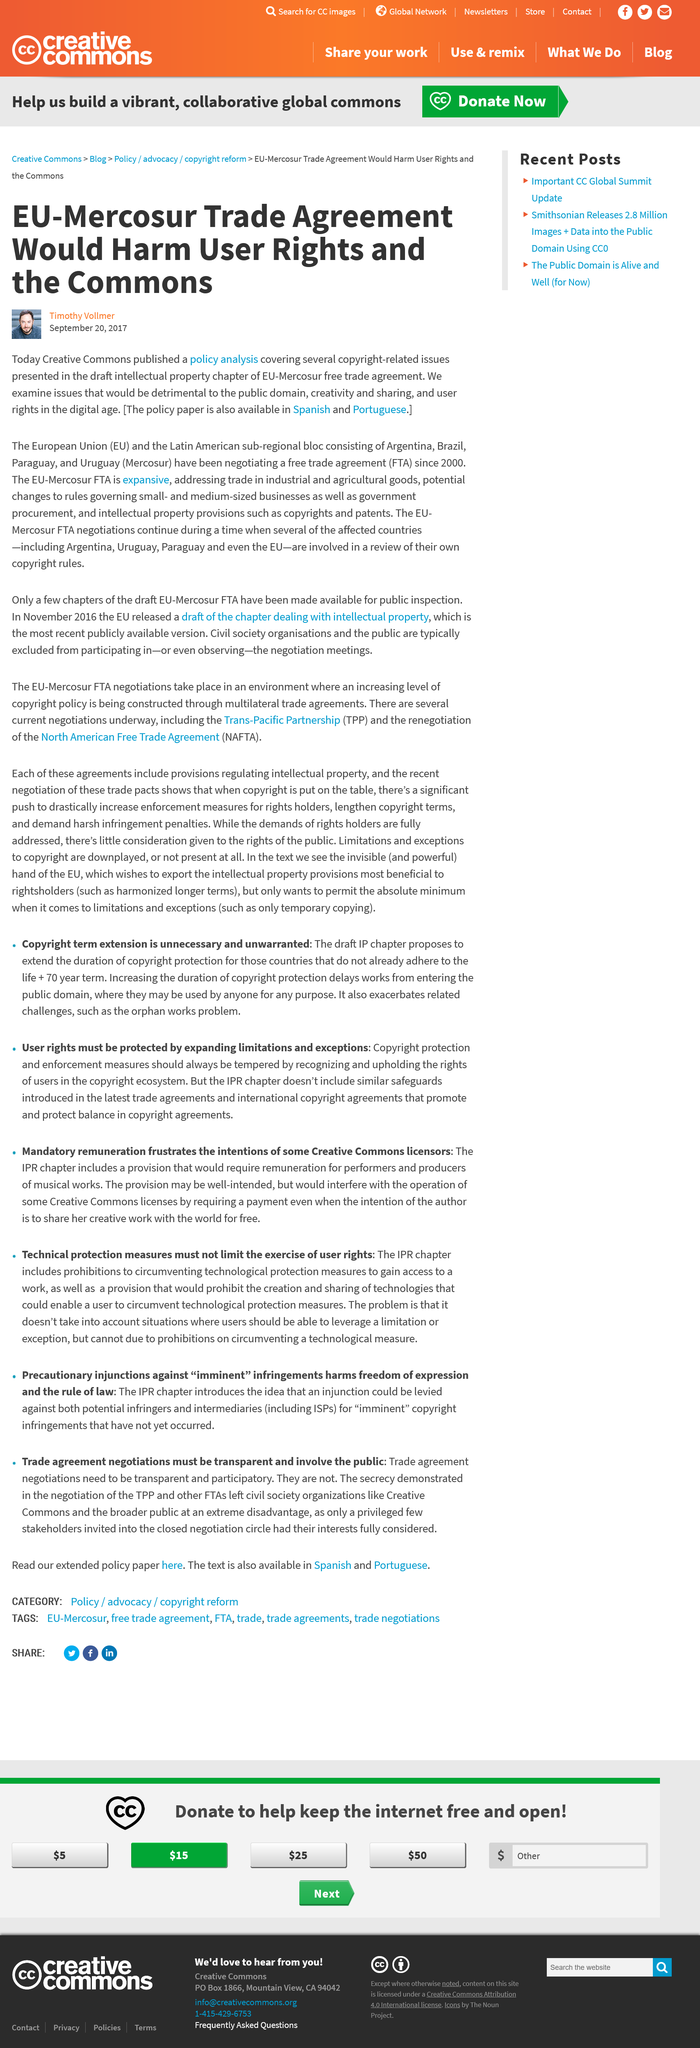List a handful of essential elements in this visual. The Eu-Mercosur Trade Agreement, as written by Timothy Vollmer, would harm user rights and the Commons. The policy analysis was published by Creative Commons. The Latin American sub-regional bloc consists of four countries, namely Argentina, Brazil, Paraguay, and Uruguay. 